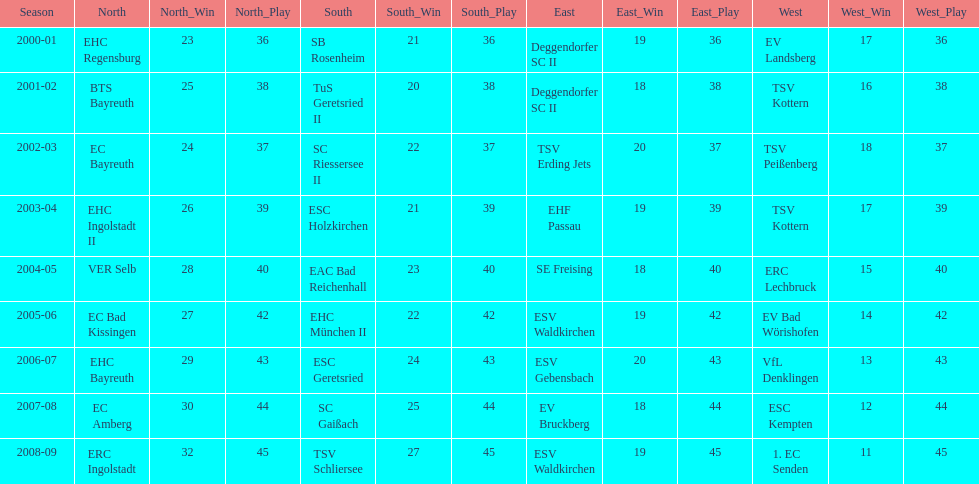Which name appears more often, kottern or bayreuth? Bayreuth. 